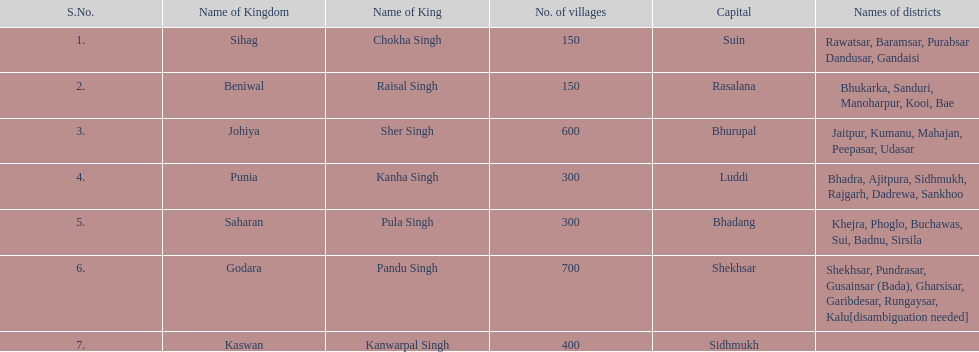Could you parse the entire table? {'header': ['S.No.', 'Name of Kingdom', 'Name of King', 'No. of villages', 'Capital', 'Names of districts'], 'rows': [['1.', 'Sihag', 'Chokha Singh', '150', 'Suin', 'Rawatsar, Baramsar, Purabsar Dandusar, Gandaisi'], ['2.', 'Beniwal', 'Raisal Singh', '150', 'Rasalana', 'Bhukarka, Sanduri, Manoharpur, Kooi, Bae'], ['3.', 'Johiya', 'Sher Singh', '600', 'Bhurupal', 'Jaitpur, Kumanu, Mahajan, Peepasar, Udasar'], ['4.', 'Punia', 'Kanha Singh', '300', 'Luddi', 'Bhadra, Ajitpura, Sidhmukh, Rajgarh, Dadrewa, Sankhoo'], ['5.', 'Saharan', 'Pula Singh', '300', 'Bhadang', 'Khejra, Phoglo, Buchawas, Sui, Badnu, Sirsila'], ['6.', 'Godara', 'Pandu Singh', '700', 'Shekhsar', 'Shekhsar, Pundrasar, Gusainsar (Bada), Gharsisar, Garibdesar, Rungaysar, Kalu[disambiguation needed]'], ['7.', 'Kaswan', 'Kanwarpal Singh', '400', 'Sidhmukh', '']]} How many divisions are there in punia? 6. 